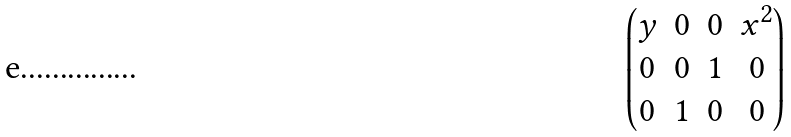Convert formula to latex. <formula><loc_0><loc_0><loc_500><loc_500>\begin{pmatrix} y & 0 & 0 & x ^ { 2 } \\ 0 & 0 & 1 & 0 \\ 0 & 1 & 0 & 0 \end{pmatrix}</formula> 